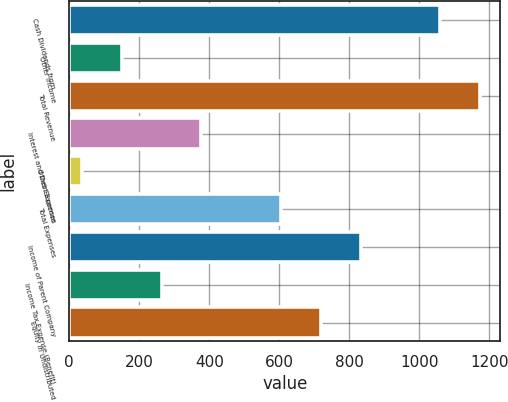Convert chart to OTSL. <chart><loc_0><loc_0><loc_500><loc_500><bar_chart><fcel>Cash Dividends from<fcel>Other Income<fcel>Total Revenue<fcel>Interest and Debt Expense<fcel>Other Expenses<fcel>Total Expenses<fcel>Income of Parent Company<fcel>Income Tax Expense (Benefit)<fcel>Equity in Undistributed<nl><fcel>1059.14<fcel>150.66<fcel>1172.7<fcel>377.78<fcel>37.1<fcel>604.9<fcel>832.02<fcel>264.22<fcel>718.46<nl></chart> 